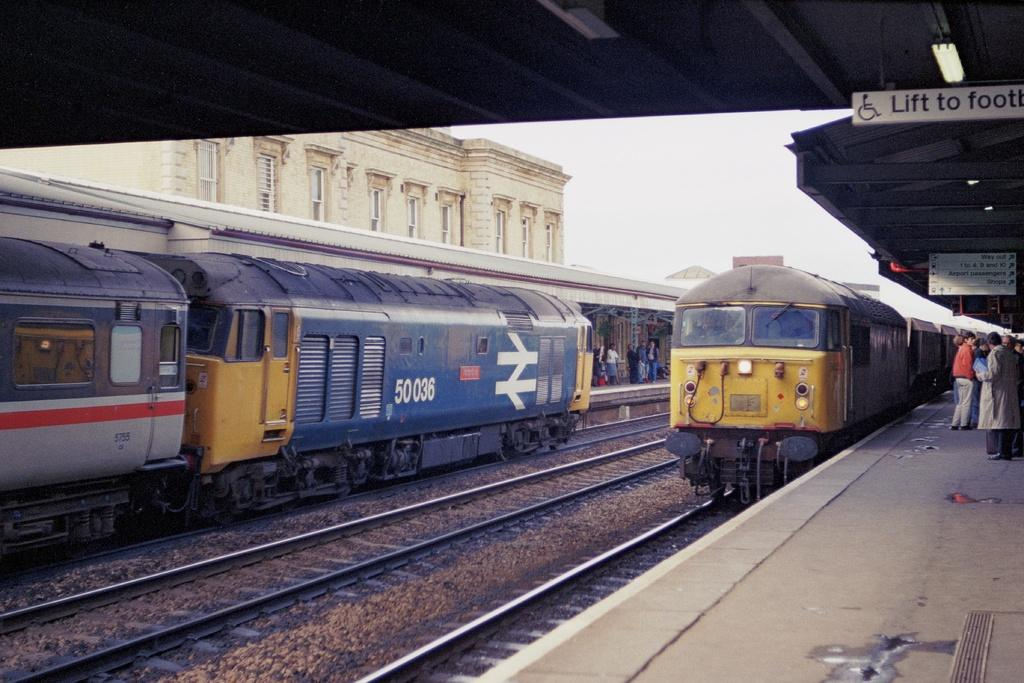<image>
Describe the image concisely. A train, numbered 50036, is at the station. 